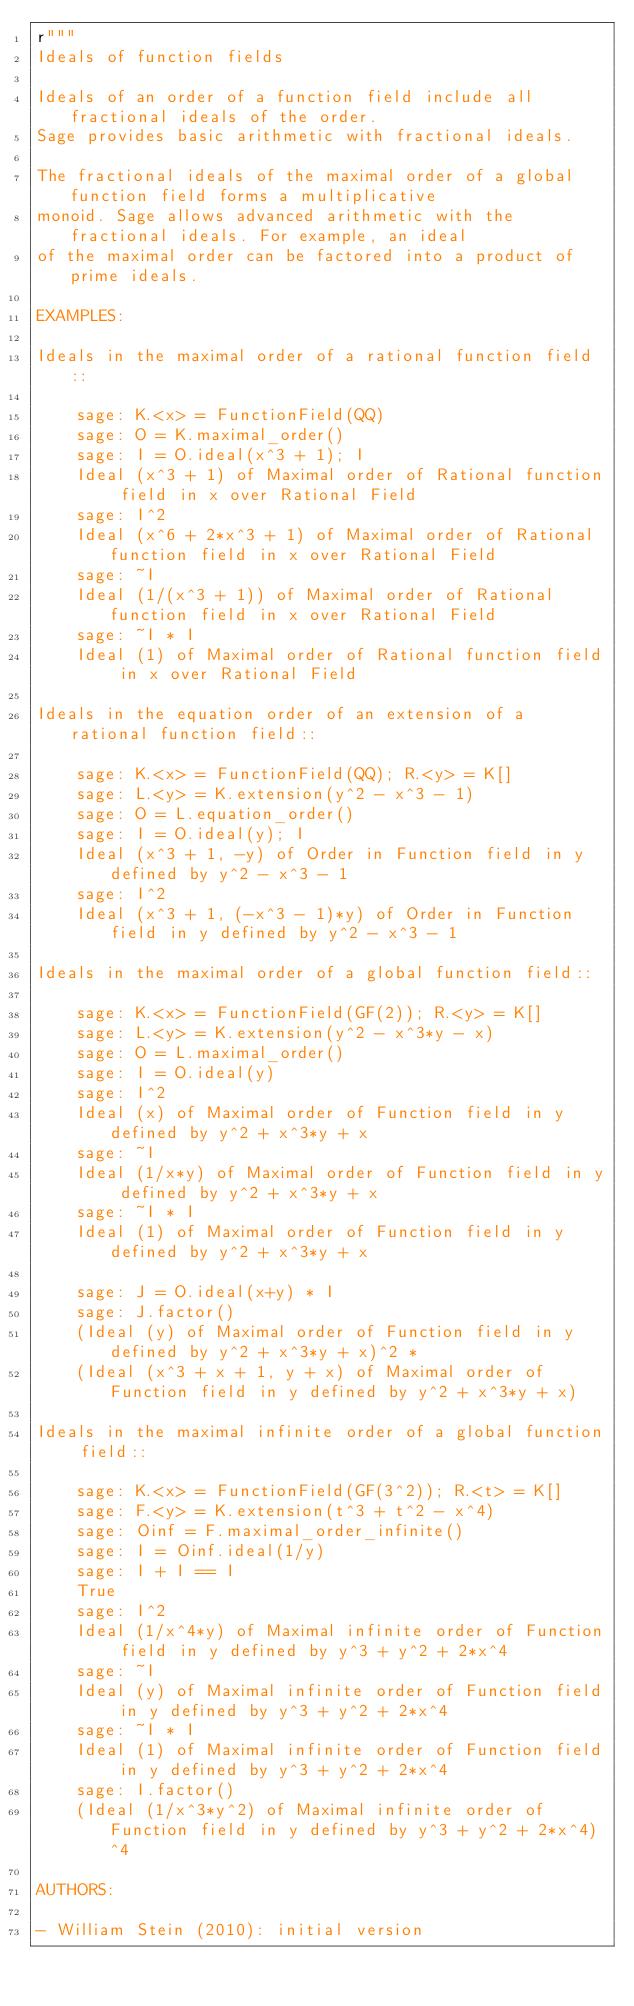<code> <loc_0><loc_0><loc_500><loc_500><_Python_>r"""
Ideals of function fields

Ideals of an order of a function field include all fractional ideals of the order.
Sage provides basic arithmetic with fractional ideals.

The fractional ideals of the maximal order of a global function field forms a multiplicative
monoid. Sage allows advanced arithmetic with the fractional ideals. For example, an ideal
of the maximal order can be factored into a product of prime ideals.

EXAMPLES:

Ideals in the maximal order of a rational function field::

    sage: K.<x> = FunctionField(QQ)
    sage: O = K.maximal_order()
    sage: I = O.ideal(x^3 + 1); I
    Ideal (x^3 + 1) of Maximal order of Rational function field in x over Rational Field
    sage: I^2
    Ideal (x^6 + 2*x^3 + 1) of Maximal order of Rational function field in x over Rational Field
    sage: ~I
    Ideal (1/(x^3 + 1)) of Maximal order of Rational function field in x over Rational Field
    sage: ~I * I
    Ideal (1) of Maximal order of Rational function field in x over Rational Field

Ideals in the equation order of an extension of a rational function field::

    sage: K.<x> = FunctionField(QQ); R.<y> = K[]
    sage: L.<y> = K.extension(y^2 - x^3 - 1)
    sage: O = L.equation_order()
    sage: I = O.ideal(y); I
    Ideal (x^3 + 1, -y) of Order in Function field in y defined by y^2 - x^3 - 1
    sage: I^2
    Ideal (x^3 + 1, (-x^3 - 1)*y) of Order in Function field in y defined by y^2 - x^3 - 1

Ideals in the maximal order of a global function field::

    sage: K.<x> = FunctionField(GF(2)); R.<y> = K[]
    sage: L.<y> = K.extension(y^2 - x^3*y - x)
    sage: O = L.maximal_order()
    sage: I = O.ideal(y)
    sage: I^2
    Ideal (x) of Maximal order of Function field in y defined by y^2 + x^3*y + x
    sage: ~I
    Ideal (1/x*y) of Maximal order of Function field in y defined by y^2 + x^3*y + x
    sage: ~I * I
    Ideal (1) of Maximal order of Function field in y defined by y^2 + x^3*y + x

    sage: J = O.ideal(x+y) * I
    sage: J.factor()
    (Ideal (y) of Maximal order of Function field in y defined by y^2 + x^3*y + x)^2 *
    (Ideal (x^3 + x + 1, y + x) of Maximal order of Function field in y defined by y^2 + x^3*y + x)

Ideals in the maximal infinite order of a global function field::

    sage: K.<x> = FunctionField(GF(3^2)); R.<t> = K[]
    sage: F.<y> = K.extension(t^3 + t^2 - x^4)
    sage: Oinf = F.maximal_order_infinite()
    sage: I = Oinf.ideal(1/y)
    sage: I + I == I
    True
    sage: I^2
    Ideal (1/x^4*y) of Maximal infinite order of Function field in y defined by y^3 + y^2 + 2*x^4
    sage: ~I
    Ideal (y) of Maximal infinite order of Function field in y defined by y^3 + y^2 + 2*x^4
    sage: ~I * I
    Ideal (1) of Maximal infinite order of Function field in y defined by y^3 + y^2 + 2*x^4
    sage: I.factor()
    (Ideal (1/x^3*y^2) of Maximal infinite order of Function field in y defined by y^3 + y^2 + 2*x^4)^4

AUTHORS:

- William Stein (2010): initial version
</code> 